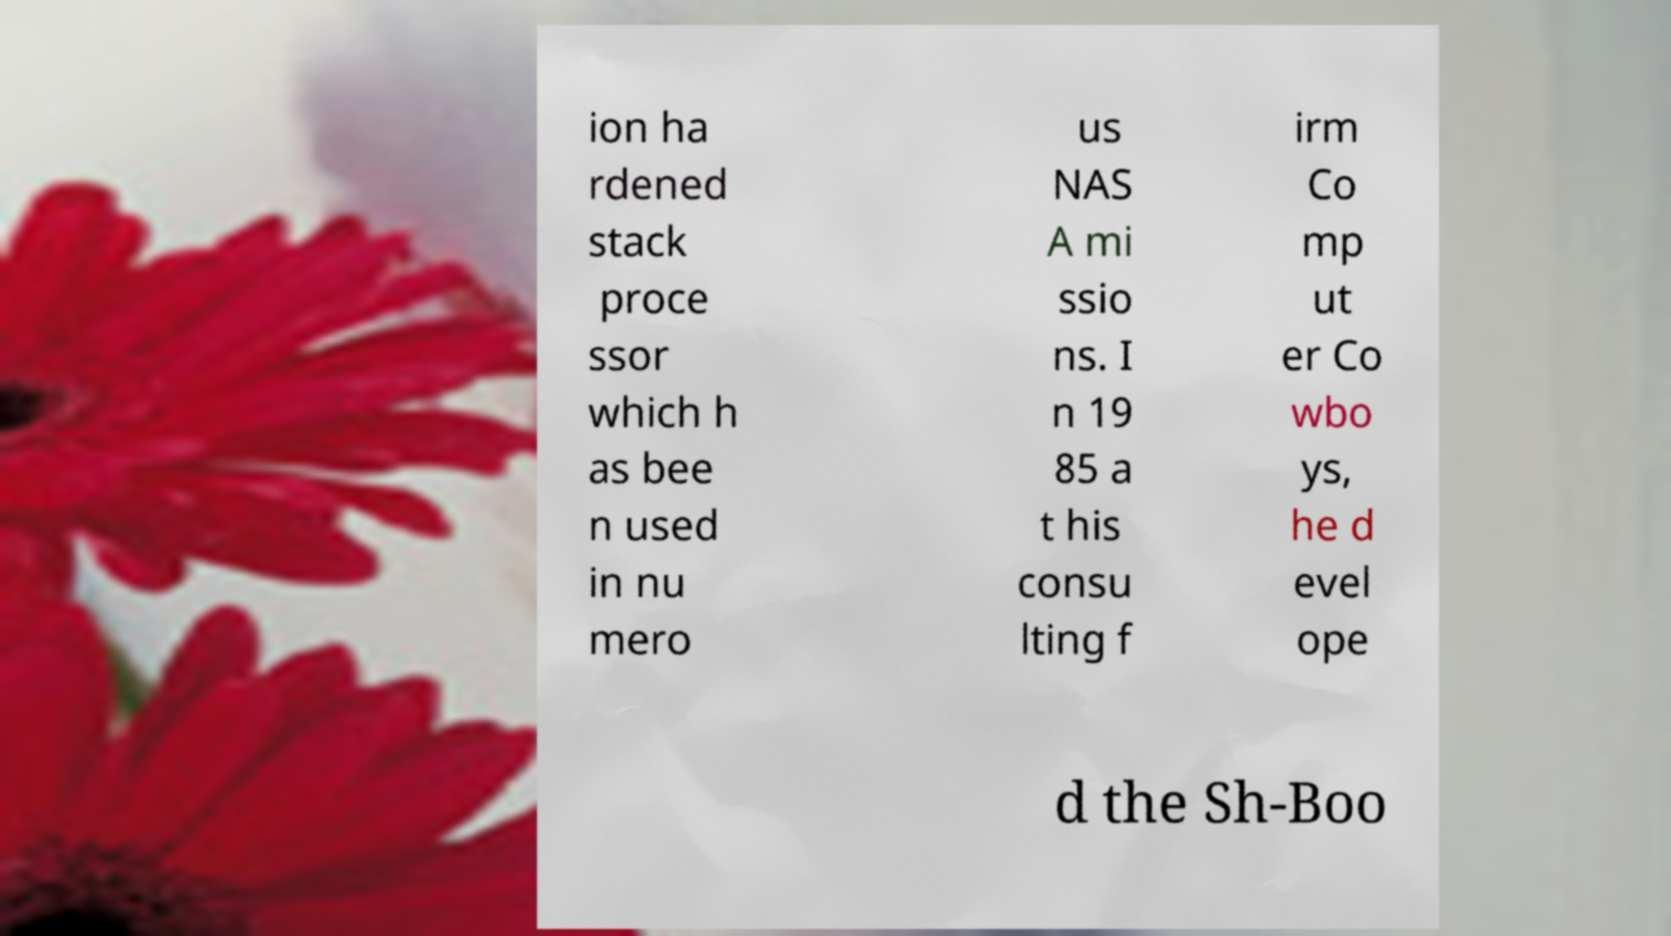Please read and relay the text visible in this image. What does it say? ion ha rdened stack proce ssor which h as bee n used in nu mero us NAS A mi ssio ns. I n 19 85 a t his consu lting f irm Co mp ut er Co wbo ys, he d evel ope d the Sh-Boo 